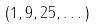<formula> <loc_0><loc_0><loc_500><loc_500>( 1 , 9 , 2 5 , \dots )</formula> 